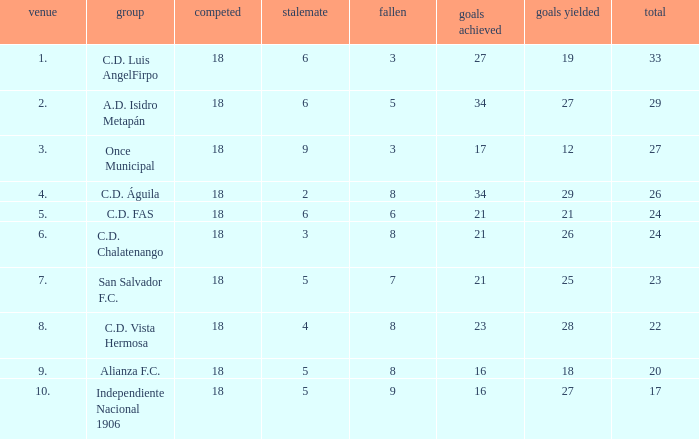What are the number of goals conceded that has a played greater than 18? 0.0. 